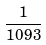<formula> <loc_0><loc_0><loc_500><loc_500>\frac { 1 } { 1 0 9 3 }</formula> 